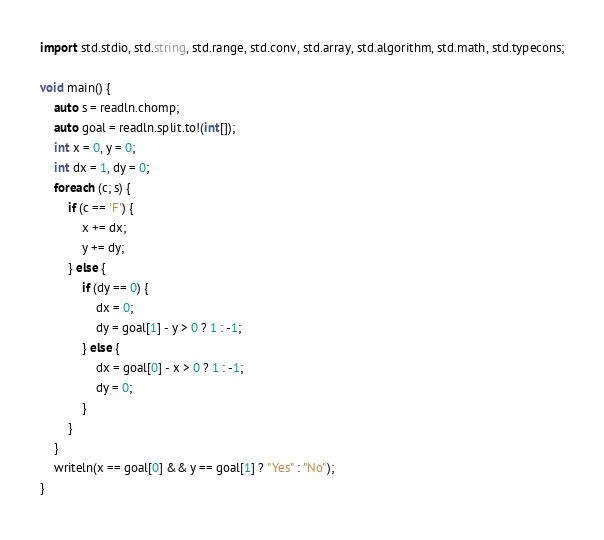Convert code to text. <code><loc_0><loc_0><loc_500><loc_500><_D_>import std.stdio, std.string, std.range, std.conv, std.array, std.algorithm, std.math, std.typecons;

void main() {
    auto s = readln.chomp;
    auto goal = readln.split.to!(int[]);
    int x = 0, y = 0;
    int dx = 1, dy = 0;
    foreach (c; s) {
        if (c == 'F') {
            x += dx;
            y += dy;
        } else {
            if (dy == 0) {
                dx = 0;
                dy = goal[1] - y > 0 ? 1 : -1;
            } else {
                dx = goal[0] - x > 0 ? 1 : -1;
                dy = 0;
            }
        }
    }
    writeln(x == goal[0] && y == goal[1] ? "Yes" : "No");
}

</code> 